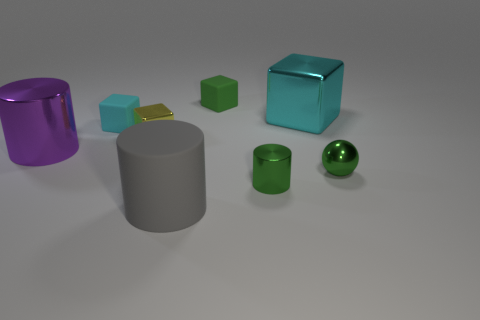What is the color of the block to the right of the green matte cube? The block to the right of the green matte cube is cyan, presenting a sleek and smooth texture that contrasts with the cube's matte finish. 